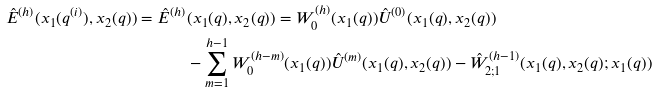Convert formula to latex. <formula><loc_0><loc_0><loc_500><loc_500>\hat { E } ^ { ( h ) } ( x _ { 1 } ( q ^ { ( i ) } ) , x _ { 2 } ( q ) ) = \hat { E } ^ { ( h ) } & ( x _ { 1 } ( q ) , x _ { 2 } ( q ) ) = W _ { 0 } ^ { ( h ) } ( x _ { 1 } ( q ) ) \hat { U } ^ { ( 0 ) } ( x _ { 1 } ( q ) , x _ { 2 } ( q ) ) \\ & - \sum _ { m = 1 } ^ { h - 1 } W _ { 0 } ^ { ( h - m ) } ( x _ { 1 } ( q ) ) \hat { U } ^ { ( m ) } ( x _ { 1 } ( q ) , x _ { 2 } ( q ) ) - \hat { W } _ { 2 ; 1 } ^ { ( h - 1 ) } ( x _ { 1 } ( q ) , x _ { 2 } ( q ) ; x _ { 1 } ( q ) )</formula> 